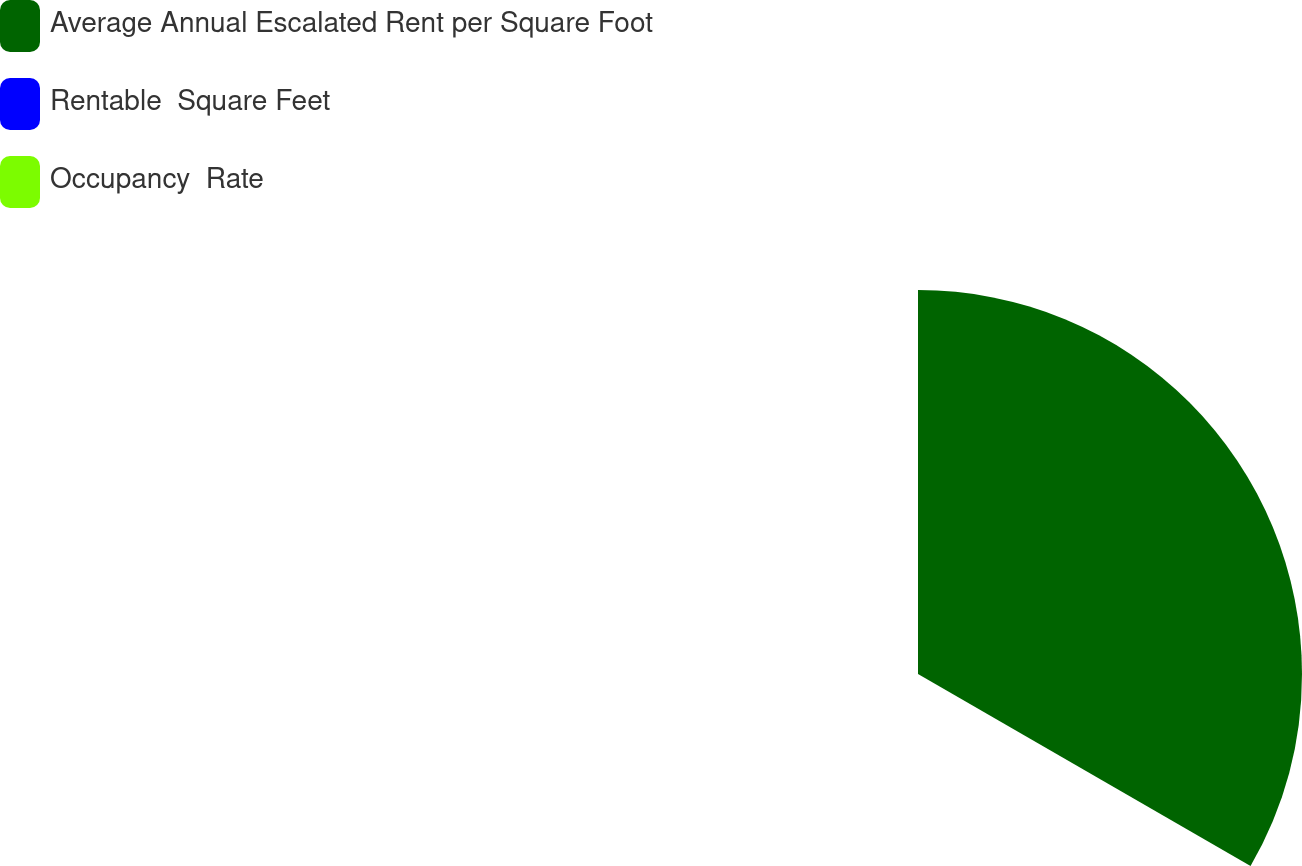<chart> <loc_0><loc_0><loc_500><loc_500><pie_chart><fcel>Average Annual Escalated Rent per Square Foot<fcel>Rentable  Square Feet<fcel>Occupancy  Rate<nl><fcel>100.0%<fcel>0.0%<fcel>0.0%<nl></chart> 